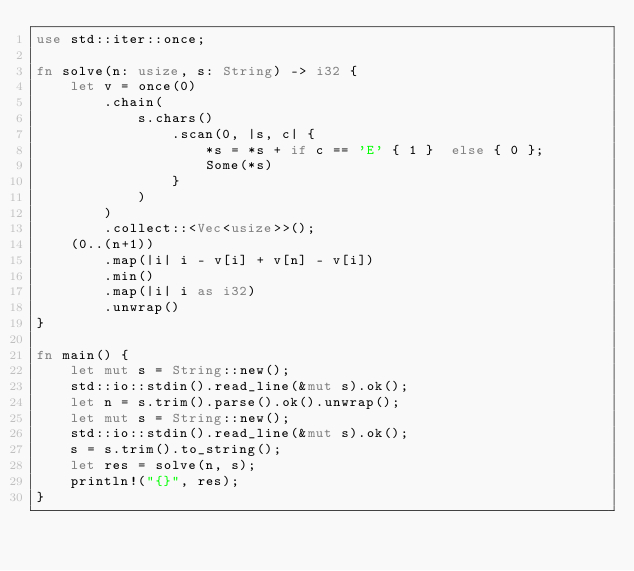<code> <loc_0><loc_0><loc_500><loc_500><_Rust_>use std::iter::once;

fn solve(n: usize, s: String) -> i32 {
    let v = once(0)
        .chain(
            s.chars()
                .scan(0, |s, c| {
                    *s = *s + if c == 'E' { 1 }  else { 0 };
                    Some(*s)
                }
            )
        )
        .collect::<Vec<usize>>();
    (0..(n+1))
        .map(|i| i - v[i] + v[n] - v[i])
        .min()
        .map(|i| i as i32)
        .unwrap()
}

fn main() {
    let mut s = String::new();
    std::io::stdin().read_line(&mut s).ok();
    let n = s.trim().parse().ok().unwrap();
    let mut s = String::new();
    std::io::stdin().read_line(&mut s).ok();
    s = s.trim().to_string();
    let res = solve(n, s);
    println!("{}", res);
}
</code> 